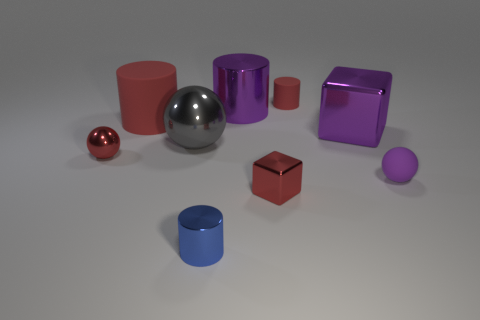Add 1 tiny purple rubber objects. How many objects exist? 10 Subtract all cylinders. How many objects are left? 5 Subtract 1 purple cylinders. How many objects are left? 8 Subtract all blue metal cylinders. Subtract all tiny metallic spheres. How many objects are left? 7 Add 8 large gray things. How many large gray things are left? 9 Add 3 tiny metallic blocks. How many tiny metallic blocks exist? 4 